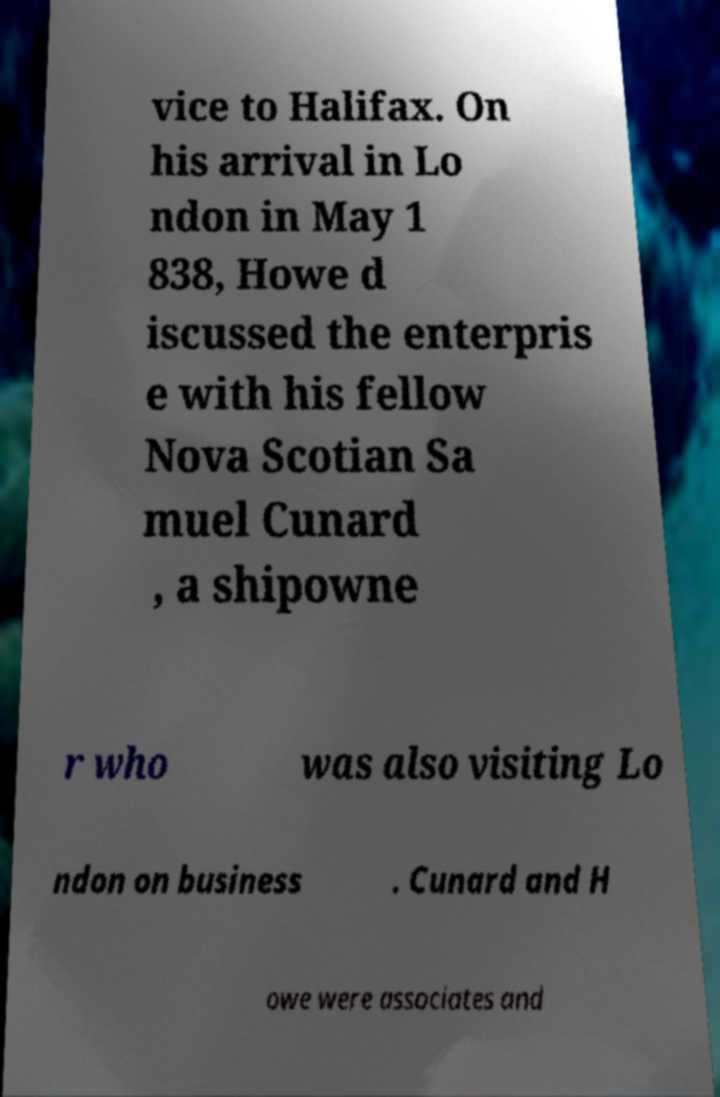Could you assist in decoding the text presented in this image and type it out clearly? vice to Halifax. On his arrival in Lo ndon in May 1 838, Howe d iscussed the enterpris e with his fellow Nova Scotian Sa muel Cunard , a shipowne r who was also visiting Lo ndon on business . Cunard and H owe were associates and 